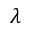<formula> <loc_0><loc_0><loc_500><loc_500>\lambda</formula> 